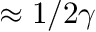Convert formula to latex. <formula><loc_0><loc_0><loc_500><loc_500>\approx 1 / 2 \gamma</formula> 